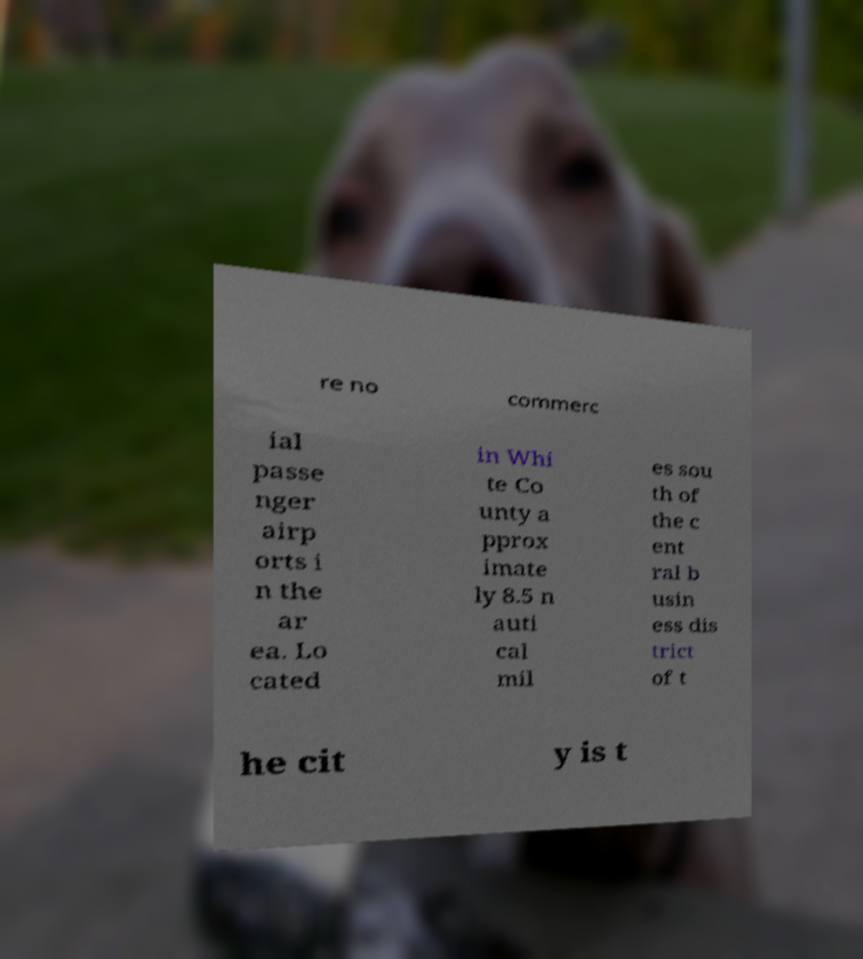Please identify and transcribe the text found in this image. re no commerc ial passe nger airp orts i n the ar ea. Lo cated in Whi te Co unty a pprox imate ly 8.5 n auti cal mil es sou th of the c ent ral b usin ess dis trict of t he cit y is t 